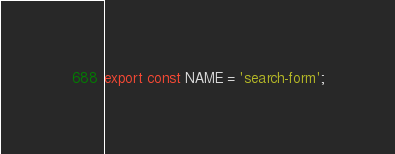<code> <loc_0><loc_0><loc_500><loc_500><_JavaScript_>export const NAME = 'search-form';
</code> 